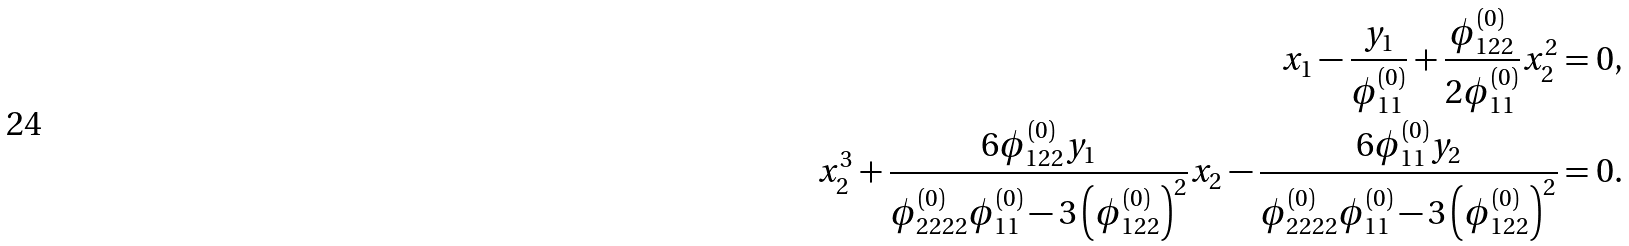<formula> <loc_0><loc_0><loc_500><loc_500>x _ { 1 } - \frac { y _ { 1 } } { \phi _ { 1 1 } ^ { ( 0 ) } } + \frac { \phi _ { 1 2 2 } ^ { ( 0 ) } } { 2 \phi _ { 1 1 } ^ { ( 0 ) } } x _ { 2 } ^ { 2 } = 0 , \\ x _ { 2 } ^ { 3 } + \frac { 6 \phi _ { 1 2 2 } ^ { ( 0 ) } y _ { 1 } } { \phi _ { 2 2 2 2 } ^ { ( 0 ) } \phi _ { 1 1 } ^ { ( 0 ) } - 3 \left ( \phi _ { 1 2 2 } ^ { ( 0 ) } \right ) ^ { 2 } } x _ { 2 } - \frac { 6 \phi _ { 1 1 } ^ { ( 0 ) } y _ { 2 } } { \phi _ { 2 2 2 2 } ^ { ( 0 ) } \phi _ { 1 1 } ^ { ( 0 ) } - 3 \left ( \phi _ { 1 2 2 } ^ { ( 0 ) } \right ) ^ { 2 } } = 0 .</formula> 